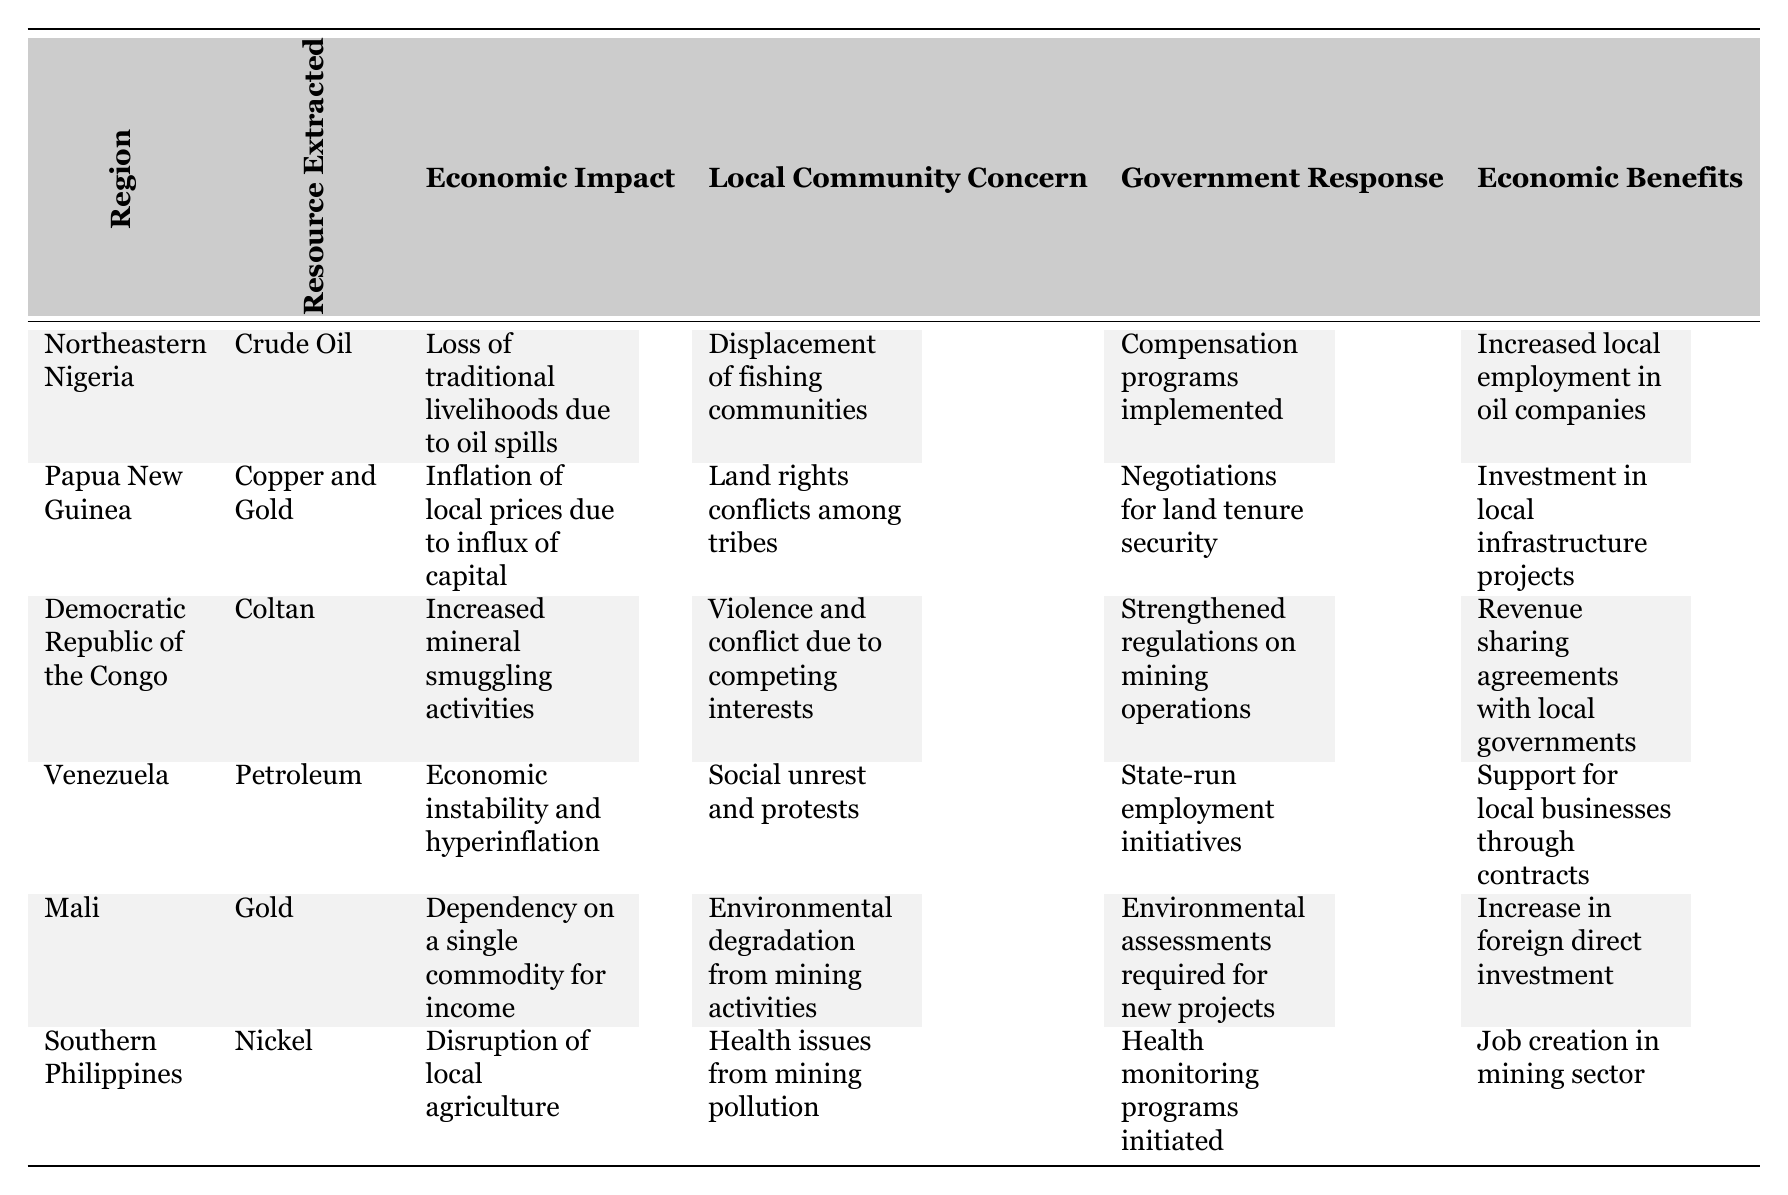What is the primary resource extracted in Venezuela? The table lists "Petroleum" as the resource extracted in the region of Venezuela.
Answer: Petroleum Which region experienced the loss of traditional livelihoods due to oil spills? According to the table, "Northeastern Nigeria" faced the loss of traditional livelihoods due to oil spills.
Answer: Northeastern Nigeria What economic benefit is associated with gold extraction in Mali? The table indicates that the economic benefit of gold extraction in Mali is an increase in foreign direct investment.
Answer: Increase in foreign direct investment Is there a government response recorded for the local community concern in Southern Philippines? Yes, the table shows that health monitoring programs were initiated as a government response to health issues from mining pollution in Southern Philippines.
Answer: Yes Which region has local community concerns related to land rights conflicts? The table states that "Papua New Guinea" has local community concerns due to land rights conflicts among tribes.
Answer: Papua New Guinea What is the economic impact associated with copper and gold extraction in Papua New Guinea? The economic impact listed for Papua New Guinea regarding copper and gold extraction is inflation of local prices due to an influx of capital.
Answer: Inflation of local prices Compare the local community concerns of the Democratic Republic of the Congo and Mali. The Democratic Republic of the Congo has concerns about violence and conflict due to competing interests, while Mali is concerned about environmental degradation from mining activities. Both represent significant societal issues.
Answer: DRC: Violence; Mali: Environmental degradation Which regions have increased local employment due to resource extraction? The table states that Northeastern Nigeria and Venezuela experienced increased local employment due to resource extraction processes within their respective regions.
Answer: Northeastern Nigeria, Venezuela What is the second economic benefit listed for the Democratic Republic of the Congo? The economic benefits for the Democratic Republic of the Congo, listed as "Revenue sharing agreements with local governments," is the only economic benefit provided. Therefore, there is no second economic benefit.
Answer: N/A What is the main economic impact of petroleum extraction in Venezuela? The main economic impact indicated in the table for petroleum extraction in Venezuela is economic instability and hyperinflation.
Answer: Economic instability and hyperinflation In how many regions is there a government response related to environment-related concerns? The regions with environment-related government responses are Mali (environmental assessments required) and Southern Philippines (health monitoring programs initiated), thus there are two such regions.
Answer: Two regions Which resource has the highest level of social unrest associated? "Petroleum" extraction in Venezuela has the highest level of social unrest associated, reflected in the local community concern regarding social unrest and protests.
Answer: Petroleum How does the economic impact of coltan extraction in the Democratic Republic of the Congo contribute to local conflict? The economic impact of coltan extraction includes increased mineral smuggling activities, which fuels violence and conflict due to competing interests among groups, making it a significant local concern.
Answer: Increased mineral smuggling causes conflict 